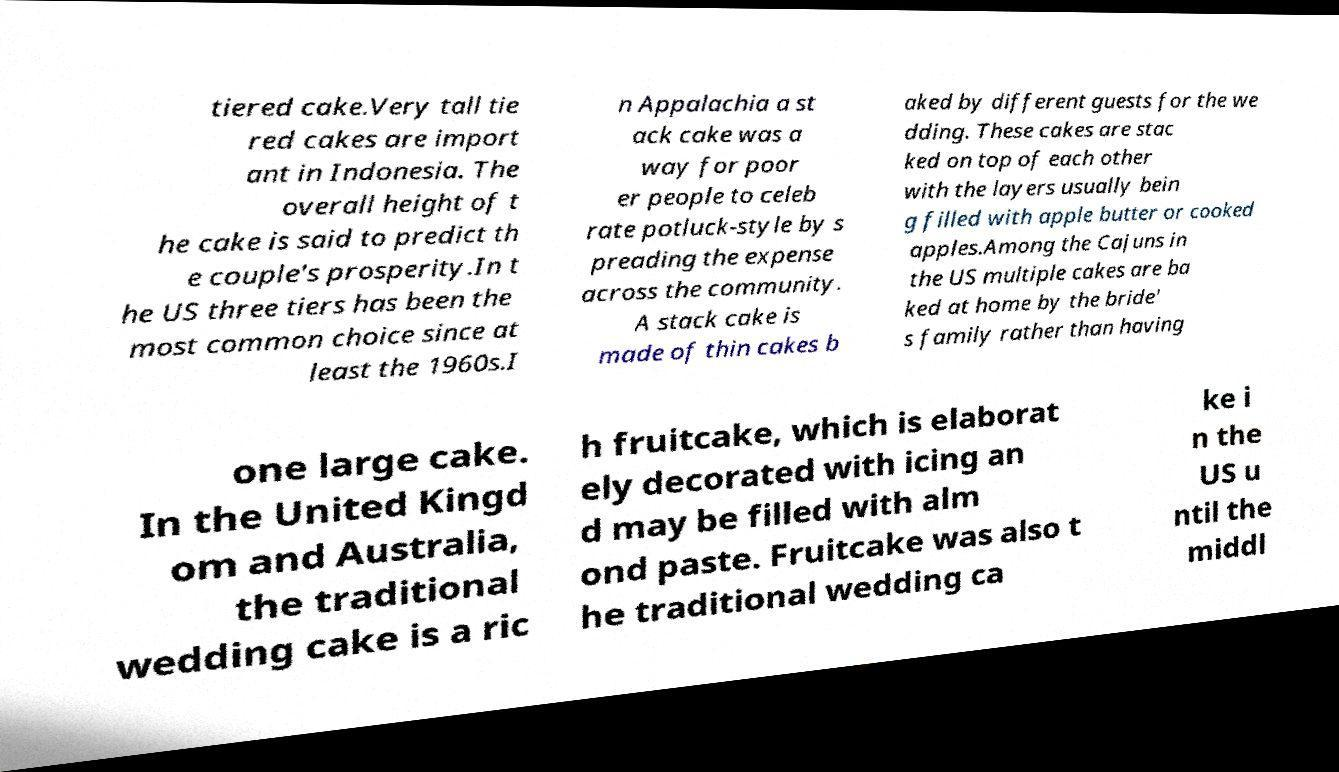Please identify and transcribe the text found in this image. tiered cake.Very tall tie red cakes are import ant in Indonesia. The overall height of t he cake is said to predict th e couple's prosperity.In t he US three tiers has been the most common choice since at least the 1960s.I n Appalachia a st ack cake was a way for poor er people to celeb rate potluck-style by s preading the expense across the community. A stack cake is made of thin cakes b aked by different guests for the we dding. These cakes are stac ked on top of each other with the layers usually bein g filled with apple butter or cooked apples.Among the Cajuns in the US multiple cakes are ba ked at home by the bride' s family rather than having one large cake. In the United Kingd om and Australia, the traditional wedding cake is a ric h fruitcake, which is elaborat ely decorated with icing an d may be filled with alm ond paste. Fruitcake was also t he traditional wedding ca ke i n the US u ntil the middl 